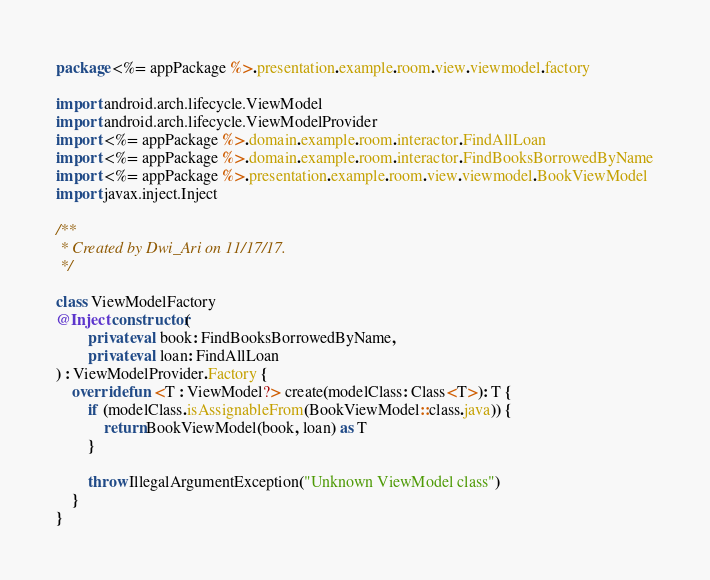<code> <loc_0><loc_0><loc_500><loc_500><_Kotlin_>package <%= appPackage %>.presentation.example.room.view.viewmodel.factory

import android.arch.lifecycle.ViewModel
import android.arch.lifecycle.ViewModelProvider
import <%= appPackage %>.domain.example.room.interactor.FindAllLoan
import <%= appPackage %>.domain.example.room.interactor.FindBooksBorrowedByName
import <%= appPackage %>.presentation.example.room.view.viewmodel.BookViewModel
import javax.inject.Inject

/**
 * Created by Dwi_Ari on 11/17/17.
 */

class ViewModelFactory
@Inject constructor(
        private val book: FindBooksBorrowedByName,
        private val loan: FindAllLoan
) : ViewModelProvider.Factory {
    override fun <T : ViewModel?> create(modelClass: Class<T>): T {
        if (modelClass.isAssignableFrom(BookViewModel::class.java)) {
            return BookViewModel(book, loan) as T
        }

        throw IllegalArgumentException("Unknown ViewModel class")
    }
}
</code> 